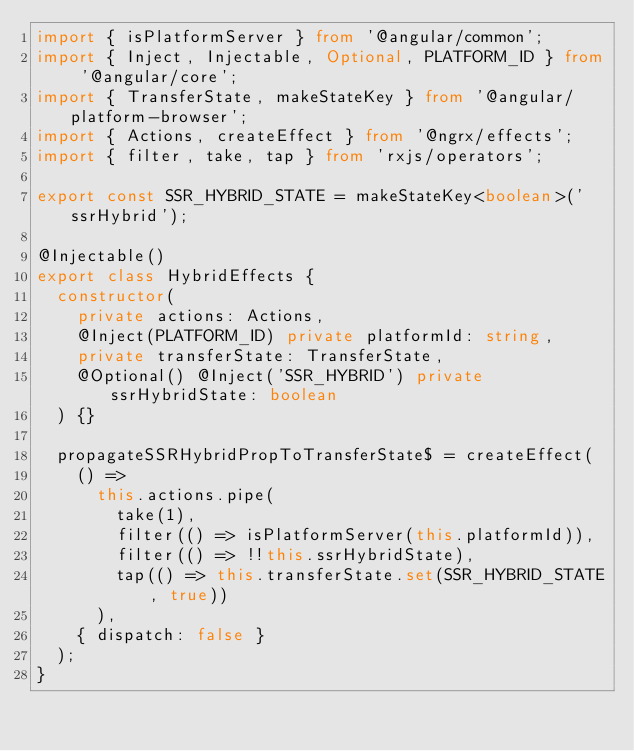<code> <loc_0><loc_0><loc_500><loc_500><_TypeScript_>import { isPlatformServer } from '@angular/common';
import { Inject, Injectable, Optional, PLATFORM_ID } from '@angular/core';
import { TransferState, makeStateKey } from '@angular/platform-browser';
import { Actions, createEffect } from '@ngrx/effects';
import { filter, take, tap } from 'rxjs/operators';

export const SSR_HYBRID_STATE = makeStateKey<boolean>('ssrHybrid');

@Injectable()
export class HybridEffects {
  constructor(
    private actions: Actions,
    @Inject(PLATFORM_ID) private platformId: string,
    private transferState: TransferState,
    @Optional() @Inject('SSR_HYBRID') private ssrHybridState: boolean
  ) {}

  propagateSSRHybridPropToTransferState$ = createEffect(
    () =>
      this.actions.pipe(
        take(1),
        filter(() => isPlatformServer(this.platformId)),
        filter(() => !!this.ssrHybridState),
        tap(() => this.transferState.set(SSR_HYBRID_STATE, true))
      ),
    { dispatch: false }
  );
}
</code> 